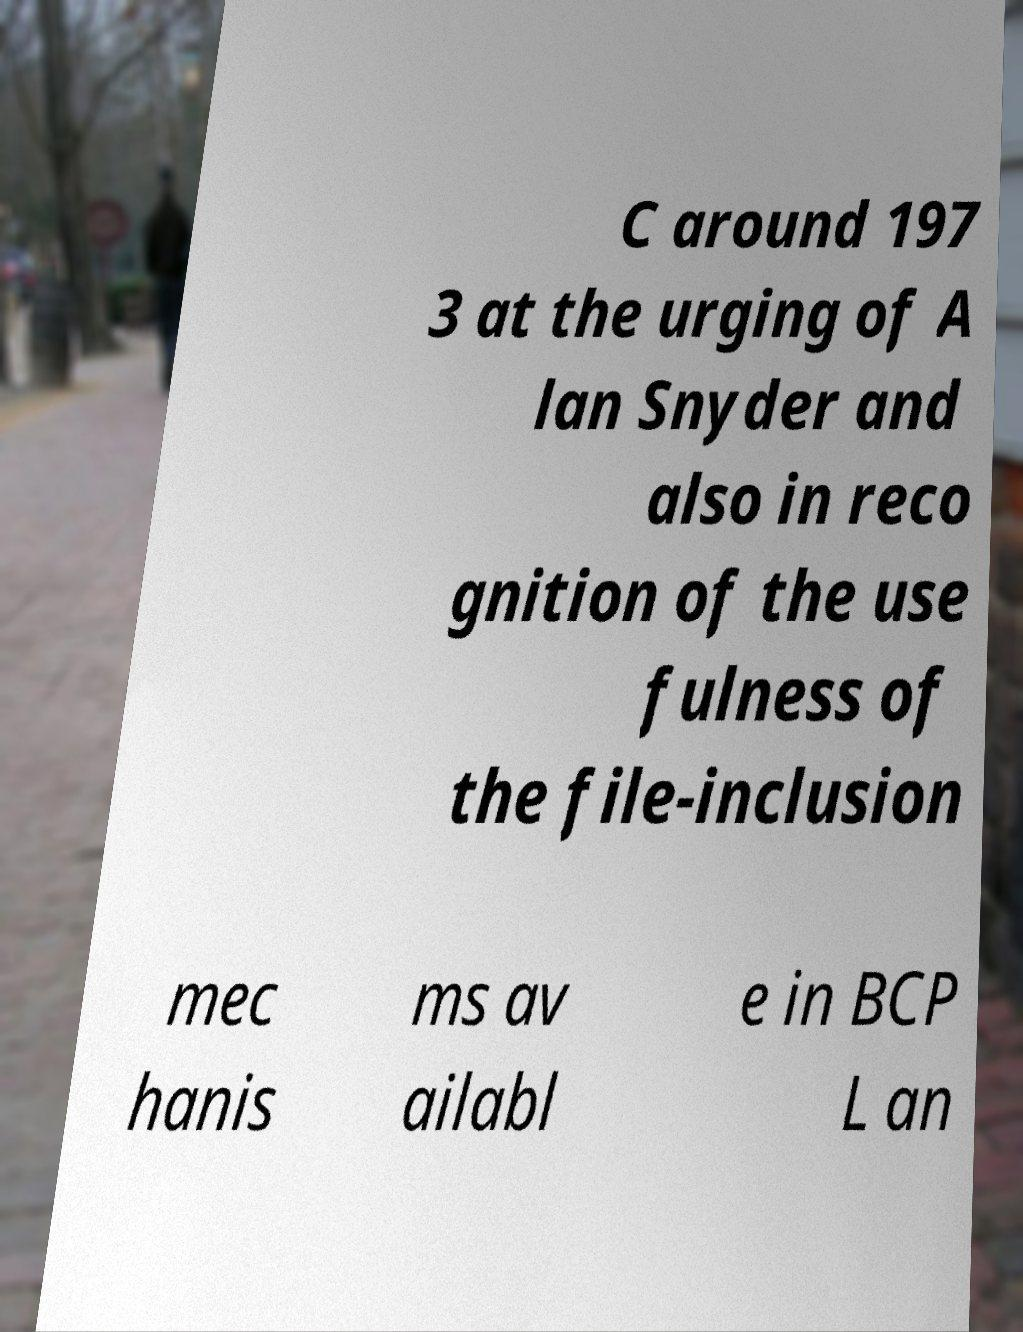Could you assist in decoding the text presented in this image and type it out clearly? C around 197 3 at the urging of A lan Snyder and also in reco gnition of the use fulness of the file-inclusion mec hanis ms av ailabl e in BCP L an 